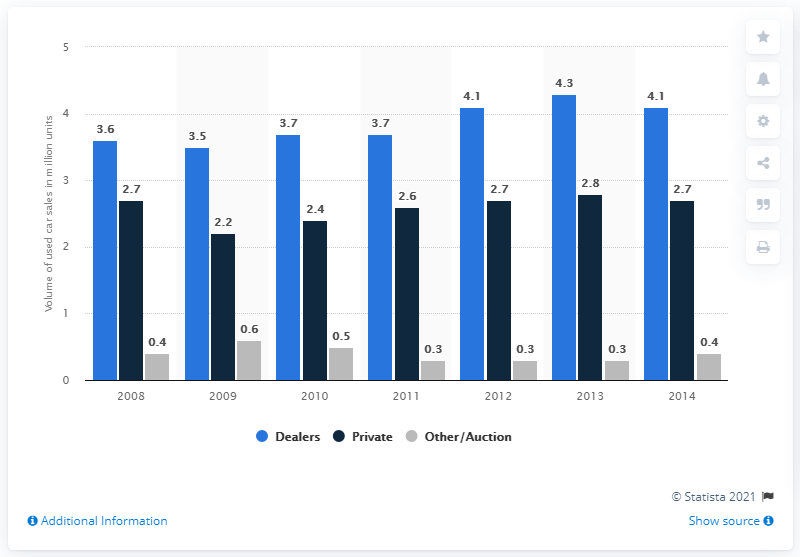Highlight a few significant elements in this photo. The highest dark blue bar has a value of 2.8. The difference between the highest and lowest dark blue bar is 0.6. 